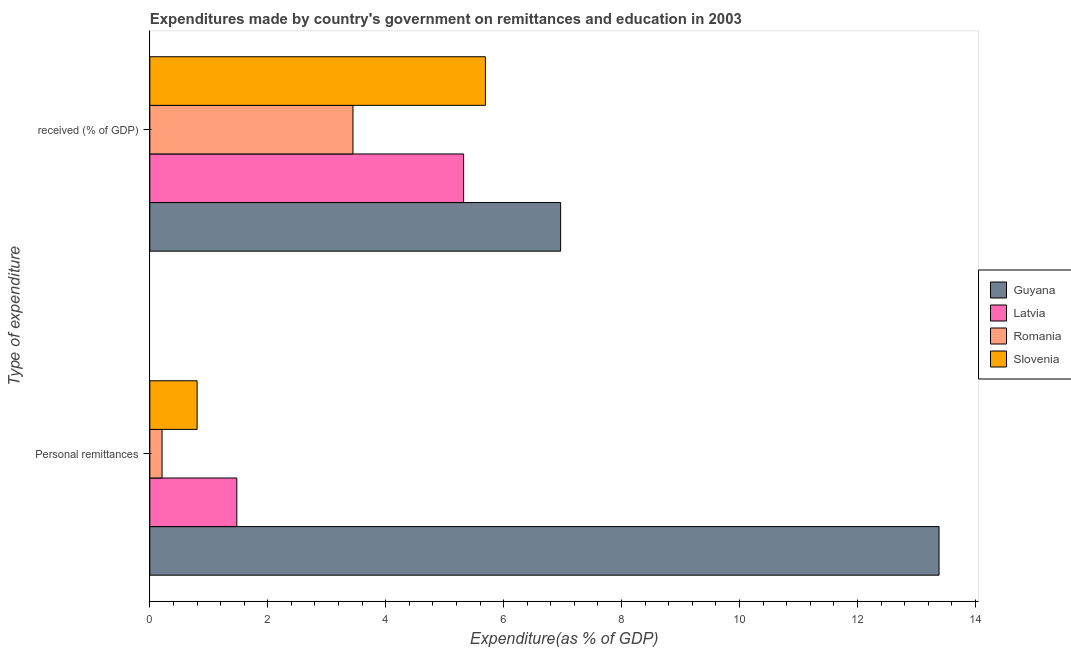Are the number of bars on each tick of the Y-axis equal?
Your answer should be compact. Yes. How many bars are there on the 1st tick from the top?
Your answer should be compact. 4. How many bars are there on the 1st tick from the bottom?
Offer a terse response. 4. What is the label of the 1st group of bars from the top?
Make the answer very short.  received (% of GDP). What is the expenditure in education in Guyana?
Ensure brevity in your answer.  6.97. Across all countries, what is the maximum expenditure in education?
Make the answer very short. 6.97. Across all countries, what is the minimum expenditure in personal remittances?
Your response must be concise. 0.21. In which country was the expenditure in personal remittances maximum?
Provide a short and direct response. Guyana. In which country was the expenditure in personal remittances minimum?
Ensure brevity in your answer.  Romania. What is the total expenditure in personal remittances in the graph?
Ensure brevity in your answer.  15.87. What is the difference between the expenditure in education in Latvia and that in Guyana?
Make the answer very short. -1.64. What is the difference between the expenditure in education in Slovenia and the expenditure in personal remittances in Guyana?
Give a very brief answer. -7.69. What is the average expenditure in personal remittances per country?
Make the answer very short. 3.97. What is the difference between the expenditure in personal remittances and expenditure in education in Guyana?
Your response must be concise. 6.42. In how many countries, is the expenditure in education greater than 10.4 %?
Your answer should be very brief. 0. What is the ratio of the expenditure in education in Latvia to that in Guyana?
Keep it short and to the point. 0.76. Is the expenditure in personal remittances in Latvia less than that in Slovenia?
Provide a short and direct response. No. What does the 4th bar from the top in  received (% of GDP) represents?
Your response must be concise. Guyana. What does the 1st bar from the bottom in  received (% of GDP) represents?
Ensure brevity in your answer.  Guyana. Are all the bars in the graph horizontal?
Make the answer very short. Yes. How many countries are there in the graph?
Offer a very short reply. 4. What is the difference between two consecutive major ticks on the X-axis?
Offer a very short reply. 2. Does the graph contain any zero values?
Provide a short and direct response. No. Does the graph contain grids?
Your answer should be compact. No. How many legend labels are there?
Offer a very short reply. 4. How are the legend labels stacked?
Provide a short and direct response. Vertical. What is the title of the graph?
Your response must be concise. Expenditures made by country's government on remittances and education in 2003. Does "Channel Islands" appear as one of the legend labels in the graph?
Keep it short and to the point. No. What is the label or title of the X-axis?
Your response must be concise. Expenditure(as % of GDP). What is the label or title of the Y-axis?
Offer a very short reply. Type of expenditure. What is the Expenditure(as % of GDP) of Guyana in Personal remittances?
Ensure brevity in your answer.  13.38. What is the Expenditure(as % of GDP) in Latvia in Personal remittances?
Give a very brief answer. 1.48. What is the Expenditure(as % of GDP) of Romania in Personal remittances?
Offer a very short reply. 0.21. What is the Expenditure(as % of GDP) of Slovenia in Personal remittances?
Your answer should be very brief. 0.8. What is the Expenditure(as % of GDP) in Guyana in  received (% of GDP)?
Your answer should be very brief. 6.97. What is the Expenditure(as % of GDP) in Latvia in  received (% of GDP)?
Offer a very short reply. 5.32. What is the Expenditure(as % of GDP) of Romania in  received (% of GDP)?
Your answer should be very brief. 3.45. What is the Expenditure(as % of GDP) of Slovenia in  received (% of GDP)?
Provide a short and direct response. 5.69. Across all Type of expenditure, what is the maximum Expenditure(as % of GDP) in Guyana?
Offer a terse response. 13.38. Across all Type of expenditure, what is the maximum Expenditure(as % of GDP) of Latvia?
Your answer should be very brief. 5.32. Across all Type of expenditure, what is the maximum Expenditure(as % of GDP) in Romania?
Your answer should be very brief. 3.45. Across all Type of expenditure, what is the maximum Expenditure(as % of GDP) in Slovenia?
Offer a terse response. 5.69. Across all Type of expenditure, what is the minimum Expenditure(as % of GDP) in Guyana?
Offer a terse response. 6.97. Across all Type of expenditure, what is the minimum Expenditure(as % of GDP) in Latvia?
Provide a short and direct response. 1.48. Across all Type of expenditure, what is the minimum Expenditure(as % of GDP) in Romania?
Your response must be concise. 0.21. Across all Type of expenditure, what is the minimum Expenditure(as % of GDP) of Slovenia?
Offer a terse response. 0.8. What is the total Expenditure(as % of GDP) of Guyana in the graph?
Your response must be concise. 20.35. What is the total Expenditure(as % of GDP) in Latvia in the graph?
Provide a succinct answer. 6.8. What is the total Expenditure(as % of GDP) of Romania in the graph?
Your answer should be very brief. 3.65. What is the total Expenditure(as % of GDP) of Slovenia in the graph?
Keep it short and to the point. 6.49. What is the difference between the Expenditure(as % of GDP) in Guyana in Personal remittances and that in  received (% of GDP)?
Your response must be concise. 6.42. What is the difference between the Expenditure(as % of GDP) of Latvia in Personal remittances and that in  received (% of GDP)?
Provide a short and direct response. -3.85. What is the difference between the Expenditure(as % of GDP) in Romania in Personal remittances and that in  received (% of GDP)?
Make the answer very short. -3.24. What is the difference between the Expenditure(as % of GDP) in Slovenia in Personal remittances and that in  received (% of GDP)?
Your response must be concise. -4.89. What is the difference between the Expenditure(as % of GDP) in Guyana in Personal remittances and the Expenditure(as % of GDP) in Latvia in  received (% of GDP)?
Your response must be concise. 8.06. What is the difference between the Expenditure(as % of GDP) in Guyana in Personal remittances and the Expenditure(as % of GDP) in Romania in  received (% of GDP)?
Make the answer very short. 9.94. What is the difference between the Expenditure(as % of GDP) of Guyana in Personal remittances and the Expenditure(as % of GDP) of Slovenia in  received (% of GDP)?
Offer a very short reply. 7.69. What is the difference between the Expenditure(as % of GDP) in Latvia in Personal remittances and the Expenditure(as % of GDP) in Romania in  received (% of GDP)?
Offer a terse response. -1.97. What is the difference between the Expenditure(as % of GDP) of Latvia in Personal remittances and the Expenditure(as % of GDP) of Slovenia in  received (% of GDP)?
Keep it short and to the point. -4.22. What is the difference between the Expenditure(as % of GDP) of Romania in Personal remittances and the Expenditure(as % of GDP) of Slovenia in  received (% of GDP)?
Your response must be concise. -5.48. What is the average Expenditure(as % of GDP) of Guyana per Type of expenditure?
Make the answer very short. 10.18. What is the average Expenditure(as % of GDP) in Latvia per Type of expenditure?
Make the answer very short. 3.4. What is the average Expenditure(as % of GDP) in Romania per Type of expenditure?
Provide a succinct answer. 1.83. What is the average Expenditure(as % of GDP) of Slovenia per Type of expenditure?
Offer a very short reply. 3.25. What is the difference between the Expenditure(as % of GDP) of Guyana and Expenditure(as % of GDP) of Latvia in Personal remittances?
Provide a succinct answer. 11.91. What is the difference between the Expenditure(as % of GDP) in Guyana and Expenditure(as % of GDP) in Romania in Personal remittances?
Your response must be concise. 13.18. What is the difference between the Expenditure(as % of GDP) in Guyana and Expenditure(as % of GDP) in Slovenia in Personal remittances?
Offer a terse response. 12.58. What is the difference between the Expenditure(as % of GDP) of Latvia and Expenditure(as % of GDP) of Romania in Personal remittances?
Ensure brevity in your answer.  1.27. What is the difference between the Expenditure(as % of GDP) in Latvia and Expenditure(as % of GDP) in Slovenia in Personal remittances?
Your answer should be very brief. 0.67. What is the difference between the Expenditure(as % of GDP) in Romania and Expenditure(as % of GDP) in Slovenia in Personal remittances?
Ensure brevity in your answer.  -0.59. What is the difference between the Expenditure(as % of GDP) in Guyana and Expenditure(as % of GDP) in Latvia in  received (% of GDP)?
Give a very brief answer. 1.64. What is the difference between the Expenditure(as % of GDP) of Guyana and Expenditure(as % of GDP) of Romania in  received (% of GDP)?
Give a very brief answer. 3.52. What is the difference between the Expenditure(as % of GDP) in Guyana and Expenditure(as % of GDP) in Slovenia in  received (% of GDP)?
Provide a succinct answer. 1.28. What is the difference between the Expenditure(as % of GDP) in Latvia and Expenditure(as % of GDP) in Romania in  received (% of GDP)?
Keep it short and to the point. 1.88. What is the difference between the Expenditure(as % of GDP) of Latvia and Expenditure(as % of GDP) of Slovenia in  received (% of GDP)?
Give a very brief answer. -0.37. What is the difference between the Expenditure(as % of GDP) of Romania and Expenditure(as % of GDP) of Slovenia in  received (% of GDP)?
Ensure brevity in your answer.  -2.25. What is the ratio of the Expenditure(as % of GDP) in Guyana in Personal remittances to that in  received (% of GDP)?
Provide a short and direct response. 1.92. What is the ratio of the Expenditure(as % of GDP) of Latvia in Personal remittances to that in  received (% of GDP)?
Ensure brevity in your answer.  0.28. What is the ratio of the Expenditure(as % of GDP) in Romania in Personal remittances to that in  received (% of GDP)?
Make the answer very short. 0.06. What is the ratio of the Expenditure(as % of GDP) in Slovenia in Personal remittances to that in  received (% of GDP)?
Your answer should be compact. 0.14. What is the difference between the highest and the second highest Expenditure(as % of GDP) in Guyana?
Offer a terse response. 6.42. What is the difference between the highest and the second highest Expenditure(as % of GDP) of Latvia?
Ensure brevity in your answer.  3.85. What is the difference between the highest and the second highest Expenditure(as % of GDP) of Romania?
Provide a succinct answer. 3.24. What is the difference between the highest and the second highest Expenditure(as % of GDP) of Slovenia?
Provide a succinct answer. 4.89. What is the difference between the highest and the lowest Expenditure(as % of GDP) of Guyana?
Make the answer very short. 6.42. What is the difference between the highest and the lowest Expenditure(as % of GDP) of Latvia?
Give a very brief answer. 3.85. What is the difference between the highest and the lowest Expenditure(as % of GDP) in Romania?
Offer a terse response. 3.24. What is the difference between the highest and the lowest Expenditure(as % of GDP) in Slovenia?
Your answer should be compact. 4.89. 